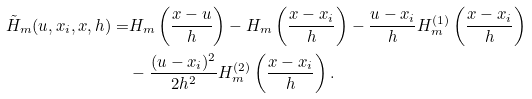Convert formula to latex. <formula><loc_0><loc_0><loc_500><loc_500>\tilde { H } _ { m } ( u , x _ { i } , x , h ) = & H _ { m } \left ( \frac { x - u } { h } \right ) - H _ { m } \left ( \frac { x - x _ { i } } { h } \right ) - \frac { u - x _ { i } } { h } H _ { m } ^ { ( 1 ) } \left ( \frac { x - x _ { i } } { h } \right ) \\ & - \frac { ( u - x _ { i } ) ^ { 2 } } { 2 h ^ { 2 } } H _ { m } ^ { ( 2 ) } \left ( \frac { x - x _ { i } } { h } \right ) .</formula> 